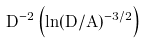<formula> <loc_0><loc_0><loc_500><loc_500>D ^ { - 2 } \left ( \ln ( D / A ) ^ { - 3 / 2 } \right )</formula> 